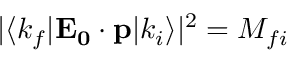<formula> <loc_0><loc_0><loc_500><loc_500>| \langle k _ { f } | E _ { 0 } \cdot p | k _ { i } \rangle | ^ { 2 } = M _ { f i }</formula> 